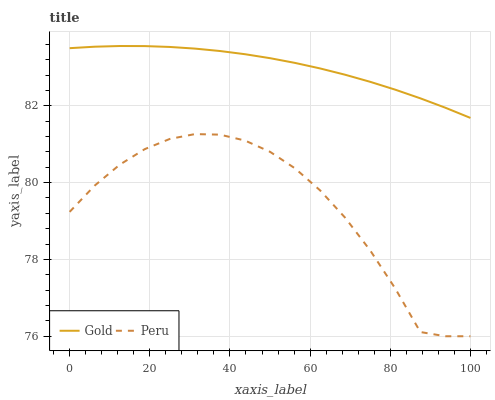Does Peru have the minimum area under the curve?
Answer yes or no. Yes. Does Gold have the maximum area under the curve?
Answer yes or no. Yes. Does Gold have the minimum area under the curve?
Answer yes or no. No. Is Gold the smoothest?
Answer yes or no. Yes. Is Peru the roughest?
Answer yes or no. Yes. Is Gold the roughest?
Answer yes or no. No. Does Peru have the lowest value?
Answer yes or no. Yes. Does Gold have the lowest value?
Answer yes or no. No. Does Gold have the highest value?
Answer yes or no. Yes. Is Peru less than Gold?
Answer yes or no. Yes. Is Gold greater than Peru?
Answer yes or no. Yes. Does Peru intersect Gold?
Answer yes or no. No. 